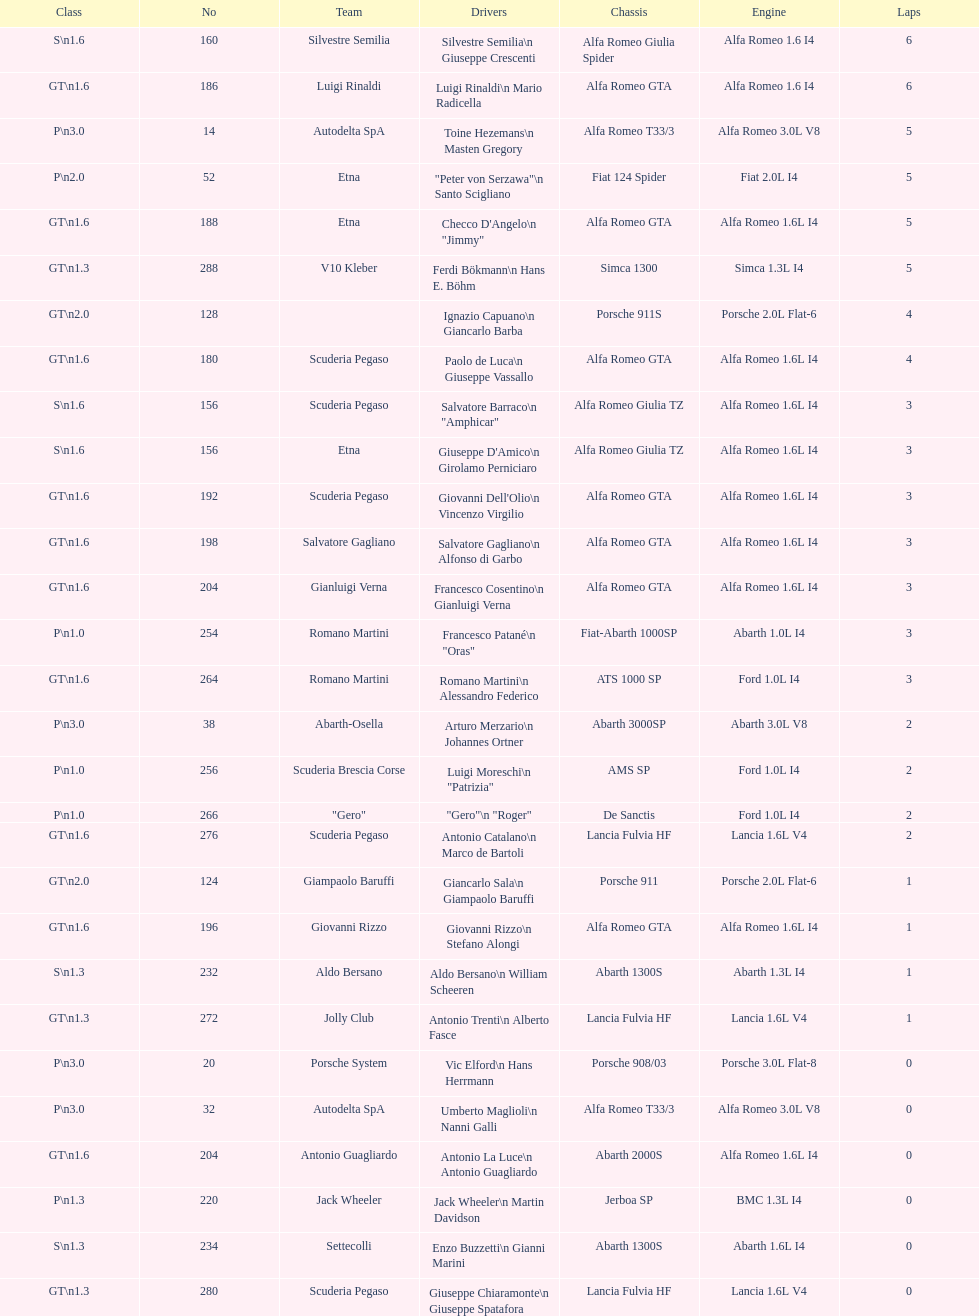Who is the only american that didn't finish the race? Masten Gregory. 